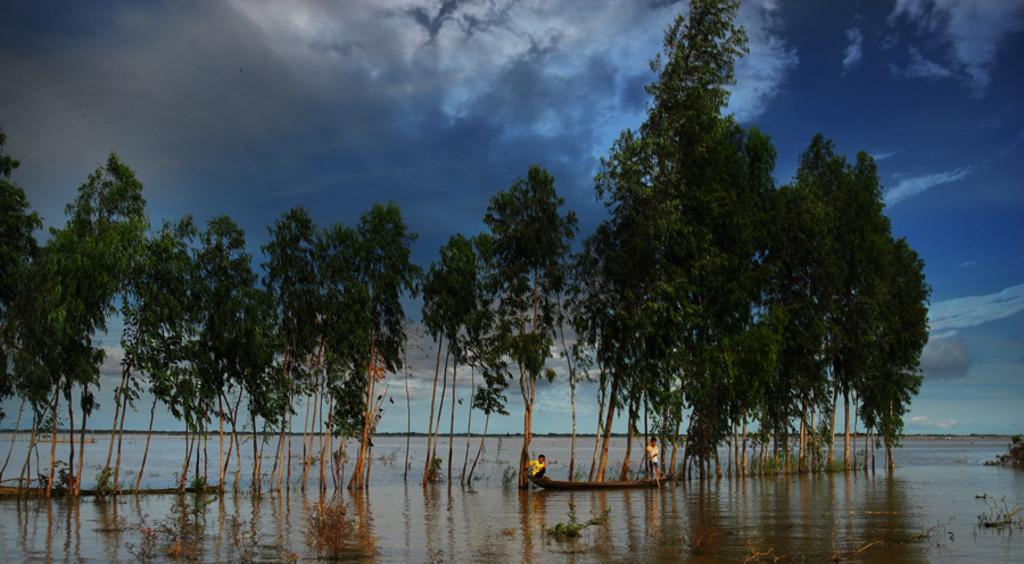How many people are in the image? There are two persons in the image. What are the persons doing in the image? The persons are sailing on a boat. Where is the boat located in the image? The boat is on a river. What type of vegetation can be seen in the image? There are trees and bushes in the image. What type of lamp is hanging from the tree in the image? There is no lamp present in the image; it features two persons sailing on a boat on a river with trees and bushes in the background. 